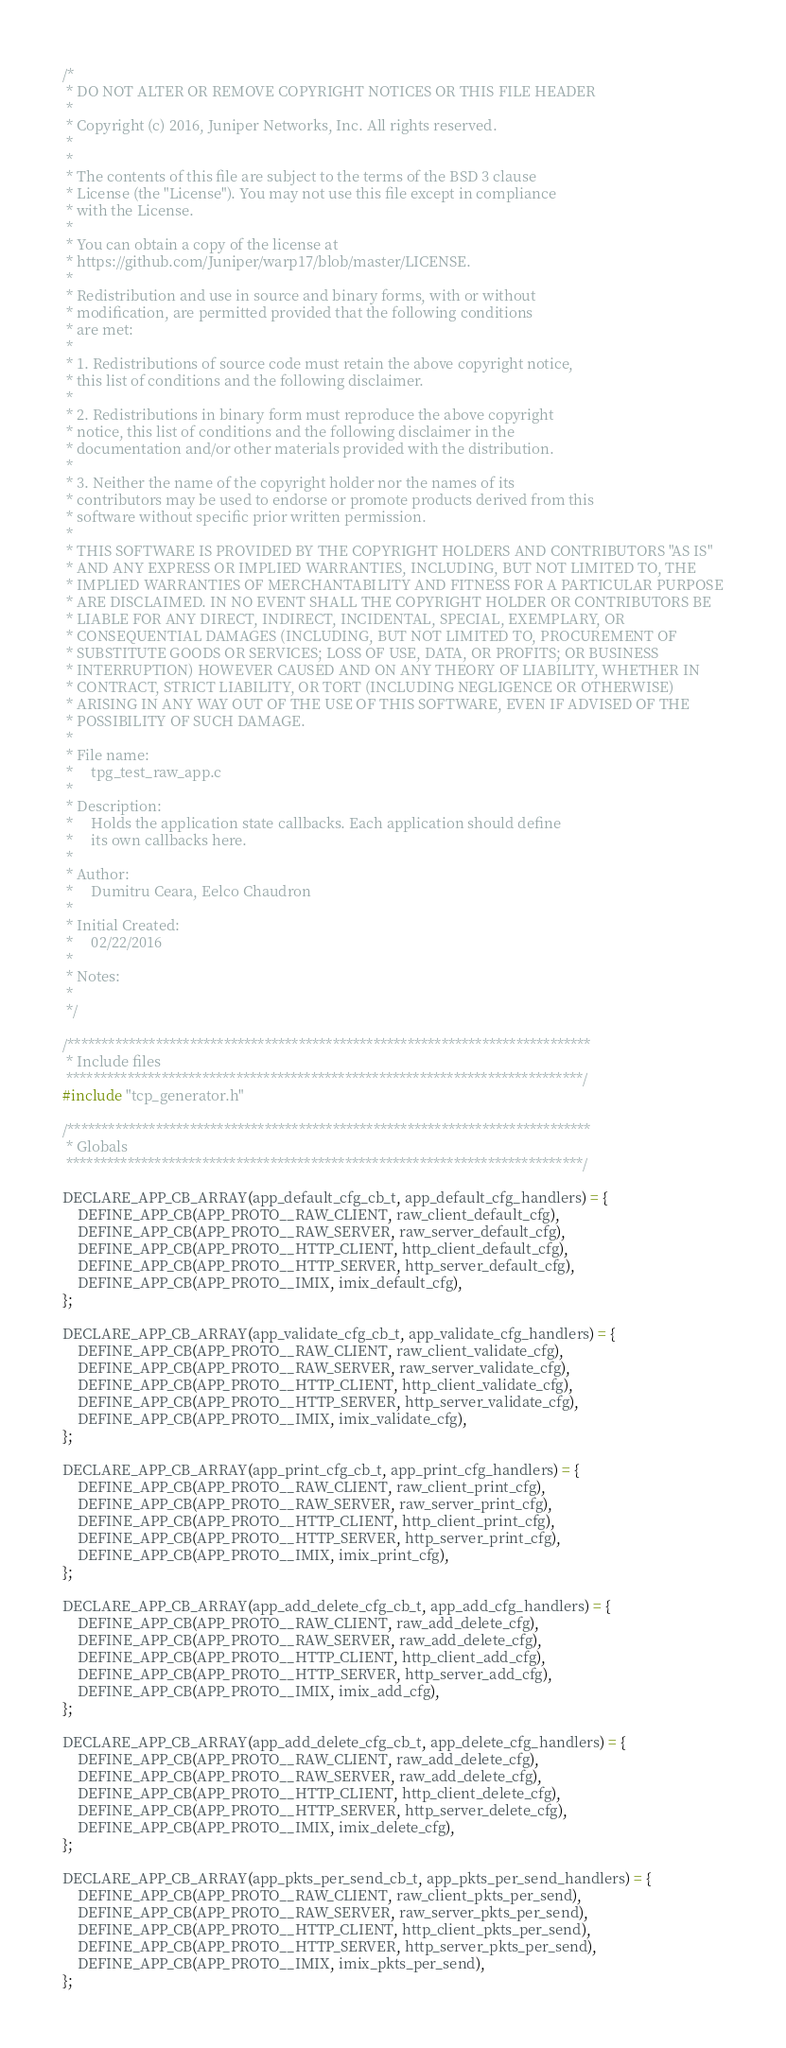Convert code to text. <code><loc_0><loc_0><loc_500><loc_500><_C_>/*
 * DO NOT ALTER OR REMOVE COPYRIGHT NOTICES OR THIS FILE HEADER
 *
 * Copyright (c) 2016, Juniper Networks, Inc. All rights reserved.
 *
 *
 * The contents of this file are subject to the terms of the BSD 3 clause
 * License (the "License"). You may not use this file except in compliance
 * with the License.
 *
 * You can obtain a copy of the license at
 * https://github.com/Juniper/warp17/blob/master/LICENSE.
 *
 * Redistribution and use in source and binary forms, with or without
 * modification, are permitted provided that the following conditions
 * are met:
 *
 * 1. Redistributions of source code must retain the above copyright notice,
 * this list of conditions and the following disclaimer.
 *
 * 2. Redistributions in binary form must reproduce the above copyright
 * notice, this list of conditions and the following disclaimer in the
 * documentation and/or other materials provided with the distribution.
 *
 * 3. Neither the name of the copyright holder nor the names of its
 * contributors may be used to endorse or promote products derived from this
 * software without specific prior written permission.
 *
 * THIS SOFTWARE IS PROVIDED BY THE COPYRIGHT HOLDERS AND CONTRIBUTORS "AS IS"
 * AND ANY EXPRESS OR IMPLIED WARRANTIES, INCLUDING, BUT NOT LIMITED TO, THE
 * IMPLIED WARRANTIES OF MERCHANTABILITY AND FITNESS FOR A PARTICULAR PURPOSE
 * ARE DISCLAIMED. IN NO EVENT SHALL THE COPYRIGHT HOLDER OR CONTRIBUTORS BE
 * LIABLE FOR ANY DIRECT, INDIRECT, INCIDENTAL, SPECIAL, EXEMPLARY, OR
 * CONSEQUENTIAL DAMAGES (INCLUDING, BUT NOT LIMITED TO, PROCUREMENT OF
 * SUBSTITUTE GOODS OR SERVICES; LOSS OF USE, DATA, OR PROFITS; OR BUSINESS
 * INTERRUPTION) HOWEVER CAUSED AND ON ANY THEORY OF LIABILITY, WHETHER IN
 * CONTRACT, STRICT LIABILITY, OR TORT (INCLUDING NEGLIGENCE OR OTHERWISE)
 * ARISING IN ANY WAY OUT OF THE USE OF THIS SOFTWARE, EVEN IF ADVISED OF THE
 * POSSIBILITY OF SUCH DAMAGE.
 *
 * File name:
 *     tpg_test_raw_app.c
 *
 * Description:
 *     Holds the application state callbacks. Each application should define
 *     its own callbacks here.
 *
 * Author:
 *     Dumitru Ceara, Eelco Chaudron
 *
 * Initial Created:
 *     02/22/2016
 *
 * Notes:
 *
 */

/*****************************************************************************
 * Include files
 ****************************************************************************/
#include "tcp_generator.h"

/*****************************************************************************
 * Globals
 ****************************************************************************/

DECLARE_APP_CB_ARRAY(app_default_cfg_cb_t, app_default_cfg_handlers) = {
    DEFINE_APP_CB(APP_PROTO__RAW_CLIENT, raw_client_default_cfg),
    DEFINE_APP_CB(APP_PROTO__RAW_SERVER, raw_server_default_cfg),
    DEFINE_APP_CB(APP_PROTO__HTTP_CLIENT, http_client_default_cfg),
    DEFINE_APP_CB(APP_PROTO__HTTP_SERVER, http_server_default_cfg),
    DEFINE_APP_CB(APP_PROTO__IMIX, imix_default_cfg),
};

DECLARE_APP_CB_ARRAY(app_validate_cfg_cb_t, app_validate_cfg_handlers) = {
    DEFINE_APP_CB(APP_PROTO__RAW_CLIENT, raw_client_validate_cfg),
    DEFINE_APP_CB(APP_PROTO__RAW_SERVER, raw_server_validate_cfg),
    DEFINE_APP_CB(APP_PROTO__HTTP_CLIENT, http_client_validate_cfg),
    DEFINE_APP_CB(APP_PROTO__HTTP_SERVER, http_server_validate_cfg),
    DEFINE_APP_CB(APP_PROTO__IMIX, imix_validate_cfg),
};

DECLARE_APP_CB_ARRAY(app_print_cfg_cb_t, app_print_cfg_handlers) = {
    DEFINE_APP_CB(APP_PROTO__RAW_CLIENT, raw_client_print_cfg),
    DEFINE_APP_CB(APP_PROTO__RAW_SERVER, raw_server_print_cfg),
    DEFINE_APP_CB(APP_PROTO__HTTP_CLIENT, http_client_print_cfg),
    DEFINE_APP_CB(APP_PROTO__HTTP_SERVER, http_server_print_cfg),
    DEFINE_APP_CB(APP_PROTO__IMIX, imix_print_cfg),
};

DECLARE_APP_CB_ARRAY(app_add_delete_cfg_cb_t, app_add_cfg_handlers) = {
    DEFINE_APP_CB(APP_PROTO__RAW_CLIENT, raw_add_delete_cfg),
    DEFINE_APP_CB(APP_PROTO__RAW_SERVER, raw_add_delete_cfg),
    DEFINE_APP_CB(APP_PROTO__HTTP_CLIENT, http_client_add_cfg),
    DEFINE_APP_CB(APP_PROTO__HTTP_SERVER, http_server_add_cfg),
    DEFINE_APP_CB(APP_PROTO__IMIX, imix_add_cfg),
};

DECLARE_APP_CB_ARRAY(app_add_delete_cfg_cb_t, app_delete_cfg_handlers) = {
    DEFINE_APP_CB(APP_PROTO__RAW_CLIENT, raw_add_delete_cfg),
    DEFINE_APP_CB(APP_PROTO__RAW_SERVER, raw_add_delete_cfg),
    DEFINE_APP_CB(APP_PROTO__HTTP_CLIENT, http_client_delete_cfg),
    DEFINE_APP_CB(APP_PROTO__HTTP_SERVER, http_server_delete_cfg),
    DEFINE_APP_CB(APP_PROTO__IMIX, imix_delete_cfg),
};

DECLARE_APP_CB_ARRAY(app_pkts_per_send_cb_t, app_pkts_per_send_handlers) = {
    DEFINE_APP_CB(APP_PROTO__RAW_CLIENT, raw_client_pkts_per_send),
    DEFINE_APP_CB(APP_PROTO__RAW_SERVER, raw_server_pkts_per_send),
    DEFINE_APP_CB(APP_PROTO__HTTP_CLIENT, http_client_pkts_per_send),
    DEFINE_APP_CB(APP_PROTO__HTTP_SERVER, http_server_pkts_per_send),
    DEFINE_APP_CB(APP_PROTO__IMIX, imix_pkts_per_send),
};
</code> 